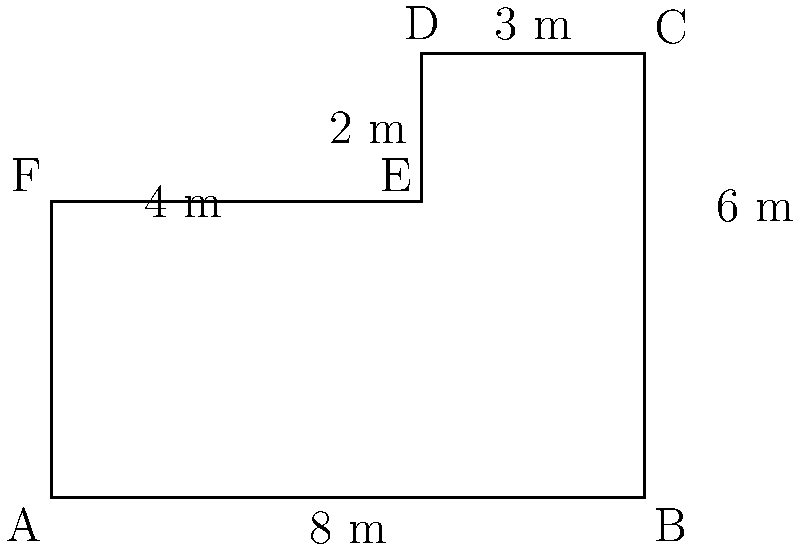Your fire station's plot has an irregular shape as shown in the diagram. Calculate the perimeter and area of this plot. How might knowing these measurements be useful for planning station improvements or emergency vehicle positioning? Let's approach this step-by-step:

1) First, we'll calculate the perimeter by adding up all the sides:
   $$ \text{Perimeter} = 8 + 6 + 3 + 2 + 4 + 4 = 27 \text{ m} $$

2) For the area, we can split the shape into a rectangle and a triangle:
   
   Rectangle: $8 \text{ m} \times 4 \text{ m} = 32 \text{ m}^2$
   
   Triangle: $\frac{1}{2} \times 3 \text{ m} \times 2 \text{ m} = 3 \text{ m}^2$

3) Total area:
   $$ \text{Area} = 32 \text{ m}^2 + 3 \text{ m}^2 = 35 \text{ m}^2 $$

4) Knowing these measurements can be useful for:
   - Planning station improvements: Understanding available space for expansions or renovations.
   - Emergency vehicle positioning: Determining optimal parking spots to ensure quick exit during emergencies.
   - Resource allocation: Deciding where to place equipment or create training areas within the available space.
   - Maintenance: Calculating materials needed for tasks like fence installation or ground maintenance.
Answer: Perimeter: 27 m, Area: 35 m². Useful for improvement planning and vehicle positioning. 